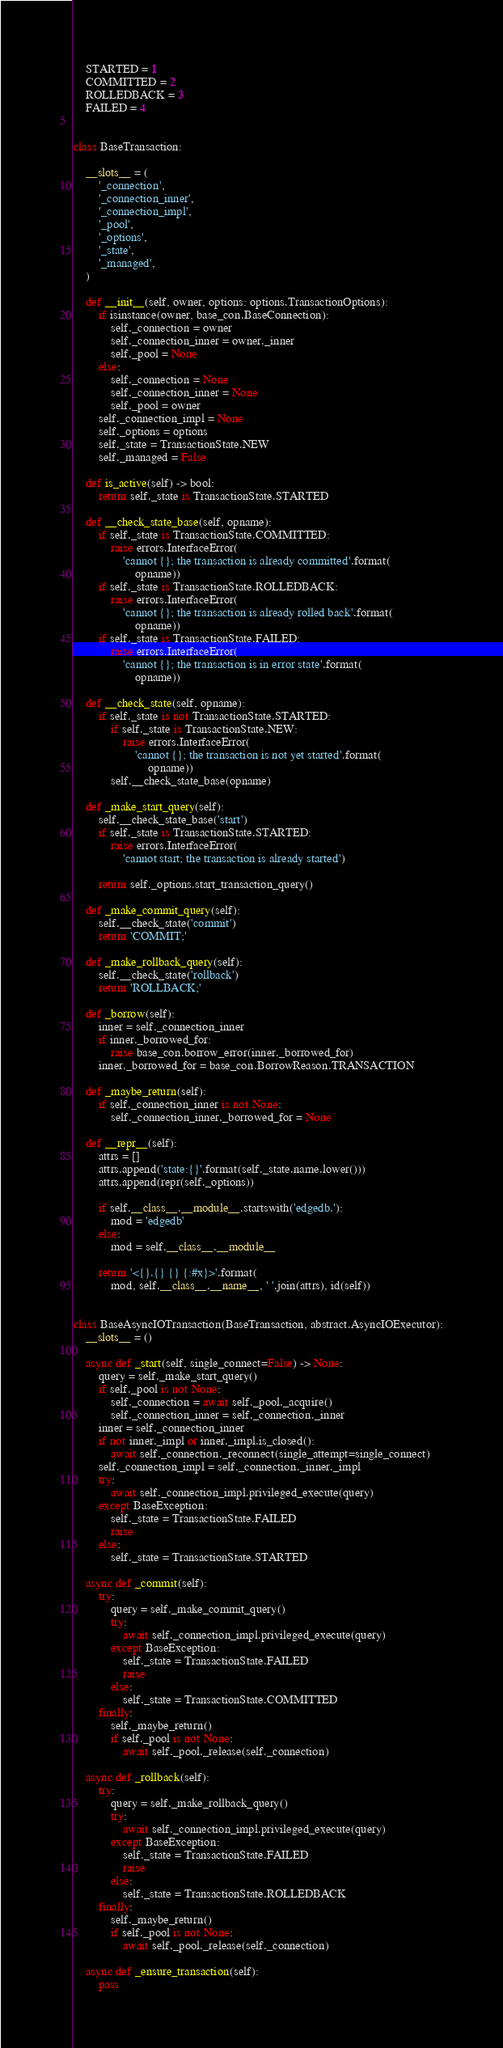Convert code to text. <code><loc_0><loc_0><loc_500><loc_500><_Python_>    STARTED = 1
    COMMITTED = 2
    ROLLEDBACK = 3
    FAILED = 4


class BaseTransaction:

    __slots__ = (
        '_connection',
        '_connection_inner',
        '_connection_impl',
        '_pool',
        '_options',
        '_state',
        '_managed',
    )

    def __init__(self, owner, options: options.TransactionOptions):
        if isinstance(owner, base_con.BaseConnection):
            self._connection = owner
            self._connection_inner = owner._inner
            self._pool = None
        else:
            self._connection = None
            self._connection_inner = None
            self._pool = owner
        self._connection_impl = None
        self._options = options
        self._state = TransactionState.NEW
        self._managed = False

    def is_active(self) -> bool:
        return self._state is TransactionState.STARTED

    def __check_state_base(self, opname):
        if self._state is TransactionState.COMMITTED:
            raise errors.InterfaceError(
                'cannot {}; the transaction is already committed'.format(
                    opname))
        if self._state is TransactionState.ROLLEDBACK:
            raise errors.InterfaceError(
                'cannot {}; the transaction is already rolled back'.format(
                    opname))
        if self._state is TransactionState.FAILED:
            raise errors.InterfaceError(
                'cannot {}; the transaction is in error state'.format(
                    opname))

    def __check_state(self, opname):
        if self._state is not TransactionState.STARTED:
            if self._state is TransactionState.NEW:
                raise errors.InterfaceError(
                    'cannot {}; the transaction is not yet started'.format(
                        opname))
            self.__check_state_base(opname)

    def _make_start_query(self):
        self.__check_state_base('start')
        if self._state is TransactionState.STARTED:
            raise errors.InterfaceError(
                'cannot start; the transaction is already started')

        return self._options.start_transaction_query()

    def _make_commit_query(self):
        self.__check_state('commit')
        return 'COMMIT;'

    def _make_rollback_query(self):
        self.__check_state('rollback')
        return 'ROLLBACK;'

    def _borrow(self):
        inner = self._connection_inner
        if inner._borrowed_for:
            raise base_con.borrow_error(inner._borrowed_for)
        inner._borrowed_for = base_con.BorrowReason.TRANSACTION

    def _maybe_return(self):
        if self._connection_inner is not None:
            self._connection_inner._borrowed_for = None

    def __repr__(self):
        attrs = []
        attrs.append('state:{}'.format(self._state.name.lower()))
        attrs.append(repr(self._options))

        if self.__class__.__module__.startswith('edgedb.'):
            mod = 'edgedb'
        else:
            mod = self.__class__.__module__

        return '<{}.{} {} {:#x}>'.format(
            mod, self.__class__.__name__, ' '.join(attrs), id(self))


class BaseAsyncIOTransaction(BaseTransaction, abstract.AsyncIOExecutor):
    __slots__ = ()

    async def _start(self, single_connect=False) -> None:
        query = self._make_start_query()
        if self._pool is not None:
            self._connection = await self._pool._acquire()
            self._connection_inner = self._connection._inner
        inner = self._connection_inner
        if not inner._impl or inner._impl.is_closed():
            await self._connection._reconnect(single_attempt=single_connect)
        self._connection_impl = self._connection._inner._impl
        try:
            await self._connection_impl.privileged_execute(query)
        except BaseException:
            self._state = TransactionState.FAILED
            raise
        else:
            self._state = TransactionState.STARTED

    async def _commit(self):
        try:
            query = self._make_commit_query()
            try:
                await self._connection_impl.privileged_execute(query)
            except BaseException:
                self._state = TransactionState.FAILED
                raise
            else:
                self._state = TransactionState.COMMITTED
        finally:
            self._maybe_return()
            if self._pool is not None:
                await self._pool._release(self._connection)

    async def _rollback(self):
        try:
            query = self._make_rollback_query()
            try:
                await self._connection_impl.privileged_execute(query)
            except BaseException:
                self._state = TransactionState.FAILED
                raise
            else:
                self._state = TransactionState.ROLLEDBACK
        finally:
            self._maybe_return()
            if self._pool is not None:
                await self._pool._release(self._connection)

    async def _ensure_transaction(self):
        pass
</code> 